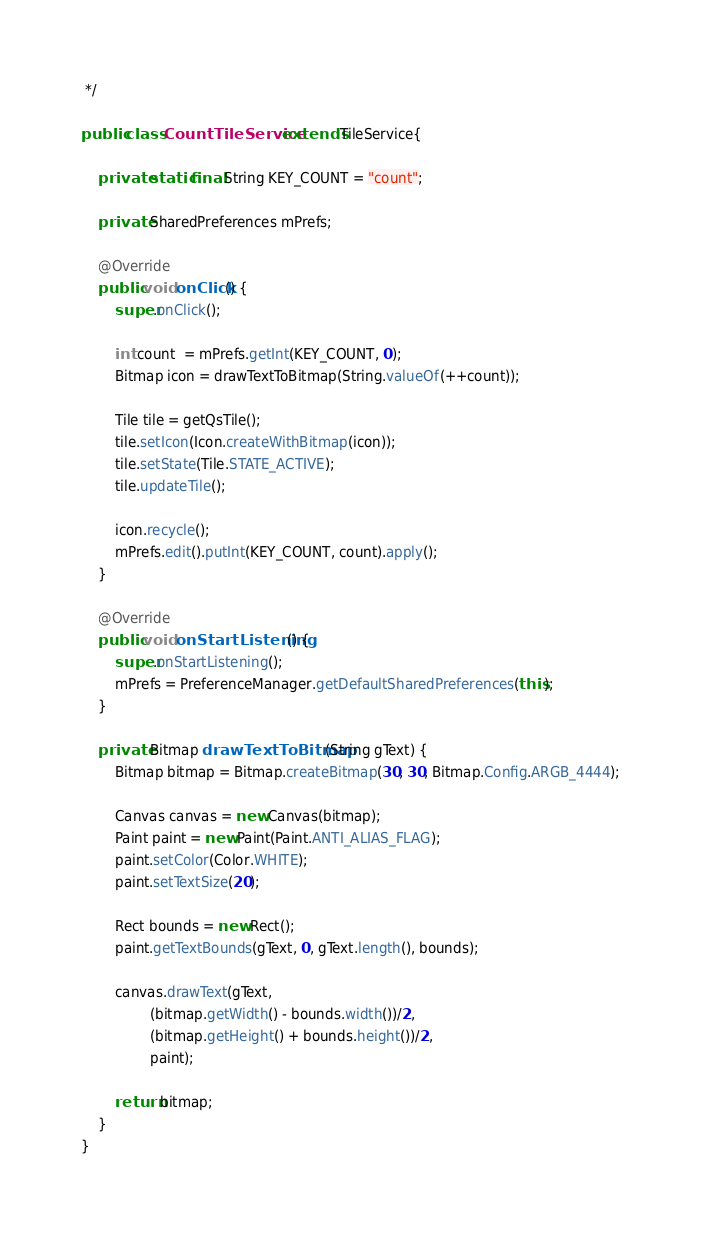Convert code to text. <code><loc_0><loc_0><loc_500><loc_500><_Java_> */

public class CountTileService extends TileService{

    private static final String KEY_COUNT = "count";

    private SharedPreferences mPrefs;

    @Override
    public void onClick() {
        super.onClick();

        int count  = mPrefs.getInt(KEY_COUNT, 0);
        Bitmap icon = drawTextToBitmap(String.valueOf(++count));

        Tile tile = getQsTile();
        tile.setIcon(Icon.createWithBitmap(icon));
        tile.setState(Tile.STATE_ACTIVE);
        tile.updateTile();

        icon.recycle();
        mPrefs.edit().putInt(KEY_COUNT, count).apply();
    }

    @Override
    public void onStartListening() {
        super.onStartListening();
        mPrefs = PreferenceManager.getDefaultSharedPreferences(this);
    }

    private Bitmap drawTextToBitmap(String gText) {
        Bitmap bitmap = Bitmap.createBitmap(30, 30, Bitmap.Config.ARGB_4444);

        Canvas canvas = new Canvas(bitmap);
        Paint paint = new Paint(Paint.ANTI_ALIAS_FLAG);
        paint.setColor(Color.WHITE);
        paint.setTextSize(20);

        Rect bounds = new Rect();
        paint.getTextBounds(gText, 0, gText.length(), bounds);

        canvas.drawText(gText,
                (bitmap.getWidth() - bounds.width())/2,
                (bitmap.getHeight() + bounds.height())/2,
                paint);

        return bitmap;
    }
}
</code> 